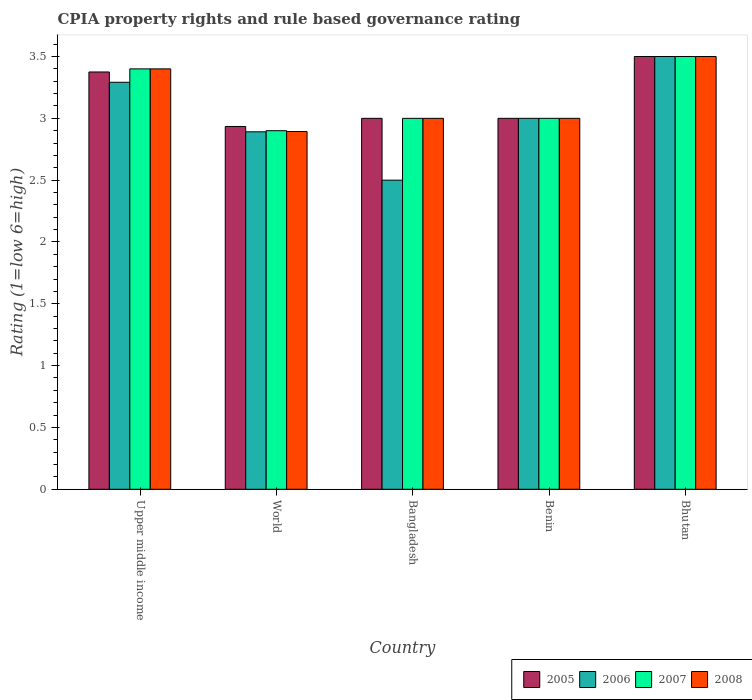How many different coloured bars are there?
Provide a succinct answer. 4. How many groups of bars are there?
Make the answer very short. 5. How many bars are there on the 3rd tick from the left?
Provide a succinct answer. 4. How many bars are there on the 2nd tick from the right?
Provide a succinct answer. 4. What is the label of the 5th group of bars from the left?
Offer a terse response. Bhutan. What is the CPIA rating in 2005 in World?
Provide a succinct answer. 2.93. Across all countries, what is the minimum CPIA rating in 2008?
Your response must be concise. 2.89. In which country was the CPIA rating in 2006 maximum?
Your answer should be very brief. Bhutan. What is the total CPIA rating in 2006 in the graph?
Provide a short and direct response. 15.18. What is the average CPIA rating in 2005 per country?
Offer a terse response. 3.16. What is the difference between the CPIA rating of/in 2007 and CPIA rating of/in 2005 in Benin?
Give a very brief answer. 0. In how many countries, is the CPIA rating in 2005 greater than 1.3?
Make the answer very short. 5. What is the ratio of the CPIA rating in 2007 in Bangladesh to that in Bhutan?
Your answer should be very brief. 0.86. Is the CPIA rating in 2007 in Bangladesh less than that in World?
Ensure brevity in your answer.  No. What is the difference between the highest and the second highest CPIA rating in 2005?
Make the answer very short. 0.38. What is the difference between the highest and the lowest CPIA rating in 2005?
Give a very brief answer. 0.57. In how many countries, is the CPIA rating in 2007 greater than the average CPIA rating in 2007 taken over all countries?
Offer a terse response. 2. Is the sum of the CPIA rating in 2006 in Bangladesh and Bhutan greater than the maximum CPIA rating in 2008 across all countries?
Keep it short and to the point. Yes. Is it the case that in every country, the sum of the CPIA rating in 2005 and CPIA rating in 2007 is greater than the sum of CPIA rating in 2006 and CPIA rating in 2008?
Give a very brief answer. No. What does the 2nd bar from the right in Benin represents?
Keep it short and to the point. 2007. Are the values on the major ticks of Y-axis written in scientific E-notation?
Provide a short and direct response. No. Does the graph contain any zero values?
Make the answer very short. No. Does the graph contain grids?
Your answer should be compact. No. What is the title of the graph?
Your response must be concise. CPIA property rights and rule based governance rating. Does "1994" appear as one of the legend labels in the graph?
Your answer should be very brief. No. What is the label or title of the Y-axis?
Offer a very short reply. Rating (1=low 6=high). What is the Rating (1=low 6=high) of 2005 in Upper middle income?
Provide a succinct answer. 3.38. What is the Rating (1=low 6=high) in 2006 in Upper middle income?
Provide a succinct answer. 3.29. What is the Rating (1=low 6=high) of 2005 in World?
Provide a short and direct response. 2.93. What is the Rating (1=low 6=high) of 2006 in World?
Offer a very short reply. 2.89. What is the Rating (1=low 6=high) in 2007 in World?
Provide a succinct answer. 2.9. What is the Rating (1=low 6=high) in 2008 in World?
Keep it short and to the point. 2.89. What is the Rating (1=low 6=high) of 2005 in Bangladesh?
Your response must be concise. 3. What is the Rating (1=low 6=high) in 2006 in Bangladesh?
Provide a short and direct response. 2.5. What is the Rating (1=low 6=high) in 2007 in Bangladesh?
Keep it short and to the point. 3. What is the Rating (1=low 6=high) of 2008 in Benin?
Ensure brevity in your answer.  3. What is the Rating (1=low 6=high) in 2005 in Bhutan?
Your answer should be very brief. 3.5. What is the Rating (1=low 6=high) in 2007 in Bhutan?
Keep it short and to the point. 3.5. What is the Rating (1=low 6=high) in 2008 in Bhutan?
Keep it short and to the point. 3.5. Across all countries, what is the maximum Rating (1=low 6=high) in 2005?
Offer a very short reply. 3.5. Across all countries, what is the maximum Rating (1=low 6=high) of 2007?
Ensure brevity in your answer.  3.5. Across all countries, what is the minimum Rating (1=low 6=high) in 2005?
Provide a short and direct response. 2.93. Across all countries, what is the minimum Rating (1=low 6=high) of 2006?
Your answer should be very brief. 2.5. Across all countries, what is the minimum Rating (1=low 6=high) of 2008?
Make the answer very short. 2.89. What is the total Rating (1=low 6=high) of 2005 in the graph?
Ensure brevity in your answer.  15.81. What is the total Rating (1=low 6=high) in 2006 in the graph?
Provide a succinct answer. 15.18. What is the total Rating (1=low 6=high) of 2007 in the graph?
Provide a short and direct response. 15.8. What is the total Rating (1=low 6=high) of 2008 in the graph?
Provide a short and direct response. 15.79. What is the difference between the Rating (1=low 6=high) of 2005 in Upper middle income and that in World?
Your answer should be compact. 0.44. What is the difference between the Rating (1=low 6=high) in 2006 in Upper middle income and that in World?
Provide a succinct answer. 0.4. What is the difference between the Rating (1=low 6=high) of 2008 in Upper middle income and that in World?
Your response must be concise. 0.51. What is the difference between the Rating (1=low 6=high) of 2006 in Upper middle income and that in Bangladesh?
Make the answer very short. 0.79. What is the difference between the Rating (1=low 6=high) in 2007 in Upper middle income and that in Bangladesh?
Your answer should be compact. 0.4. What is the difference between the Rating (1=low 6=high) of 2008 in Upper middle income and that in Bangladesh?
Provide a succinct answer. 0.4. What is the difference between the Rating (1=low 6=high) of 2005 in Upper middle income and that in Benin?
Provide a short and direct response. 0.38. What is the difference between the Rating (1=low 6=high) of 2006 in Upper middle income and that in Benin?
Offer a very short reply. 0.29. What is the difference between the Rating (1=low 6=high) in 2005 in Upper middle income and that in Bhutan?
Provide a succinct answer. -0.12. What is the difference between the Rating (1=low 6=high) of 2006 in Upper middle income and that in Bhutan?
Provide a succinct answer. -0.21. What is the difference between the Rating (1=low 6=high) in 2008 in Upper middle income and that in Bhutan?
Your response must be concise. -0.1. What is the difference between the Rating (1=low 6=high) in 2005 in World and that in Bangladesh?
Keep it short and to the point. -0.07. What is the difference between the Rating (1=low 6=high) of 2006 in World and that in Bangladesh?
Offer a very short reply. 0.39. What is the difference between the Rating (1=low 6=high) in 2007 in World and that in Bangladesh?
Offer a terse response. -0.1. What is the difference between the Rating (1=low 6=high) of 2008 in World and that in Bangladesh?
Ensure brevity in your answer.  -0.11. What is the difference between the Rating (1=low 6=high) of 2005 in World and that in Benin?
Offer a terse response. -0.07. What is the difference between the Rating (1=low 6=high) of 2006 in World and that in Benin?
Keep it short and to the point. -0.11. What is the difference between the Rating (1=low 6=high) in 2008 in World and that in Benin?
Provide a short and direct response. -0.11. What is the difference between the Rating (1=low 6=high) in 2005 in World and that in Bhutan?
Keep it short and to the point. -0.57. What is the difference between the Rating (1=low 6=high) in 2006 in World and that in Bhutan?
Provide a short and direct response. -0.61. What is the difference between the Rating (1=low 6=high) of 2007 in World and that in Bhutan?
Give a very brief answer. -0.6. What is the difference between the Rating (1=low 6=high) in 2008 in World and that in Bhutan?
Offer a very short reply. -0.61. What is the difference between the Rating (1=low 6=high) of 2007 in Bangladesh and that in Benin?
Your answer should be compact. 0. What is the difference between the Rating (1=low 6=high) in 2005 in Bangladesh and that in Bhutan?
Make the answer very short. -0.5. What is the difference between the Rating (1=low 6=high) of 2007 in Bangladesh and that in Bhutan?
Make the answer very short. -0.5. What is the difference between the Rating (1=low 6=high) of 2005 in Benin and that in Bhutan?
Provide a succinct answer. -0.5. What is the difference between the Rating (1=low 6=high) in 2007 in Benin and that in Bhutan?
Give a very brief answer. -0.5. What is the difference between the Rating (1=low 6=high) of 2008 in Benin and that in Bhutan?
Give a very brief answer. -0.5. What is the difference between the Rating (1=low 6=high) in 2005 in Upper middle income and the Rating (1=low 6=high) in 2006 in World?
Provide a succinct answer. 0.48. What is the difference between the Rating (1=low 6=high) in 2005 in Upper middle income and the Rating (1=low 6=high) in 2007 in World?
Provide a succinct answer. 0.47. What is the difference between the Rating (1=low 6=high) in 2005 in Upper middle income and the Rating (1=low 6=high) in 2008 in World?
Provide a short and direct response. 0.48. What is the difference between the Rating (1=low 6=high) of 2006 in Upper middle income and the Rating (1=low 6=high) of 2007 in World?
Ensure brevity in your answer.  0.39. What is the difference between the Rating (1=low 6=high) in 2006 in Upper middle income and the Rating (1=low 6=high) in 2008 in World?
Give a very brief answer. 0.4. What is the difference between the Rating (1=low 6=high) of 2007 in Upper middle income and the Rating (1=low 6=high) of 2008 in World?
Give a very brief answer. 0.51. What is the difference between the Rating (1=low 6=high) of 2005 in Upper middle income and the Rating (1=low 6=high) of 2006 in Bangladesh?
Your response must be concise. 0.88. What is the difference between the Rating (1=low 6=high) of 2005 in Upper middle income and the Rating (1=low 6=high) of 2007 in Bangladesh?
Your answer should be very brief. 0.38. What is the difference between the Rating (1=low 6=high) in 2005 in Upper middle income and the Rating (1=low 6=high) in 2008 in Bangladesh?
Give a very brief answer. 0.38. What is the difference between the Rating (1=low 6=high) of 2006 in Upper middle income and the Rating (1=low 6=high) of 2007 in Bangladesh?
Your answer should be very brief. 0.29. What is the difference between the Rating (1=low 6=high) of 2006 in Upper middle income and the Rating (1=low 6=high) of 2008 in Bangladesh?
Provide a short and direct response. 0.29. What is the difference between the Rating (1=low 6=high) of 2005 in Upper middle income and the Rating (1=low 6=high) of 2007 in Benin?
Your answer should be compact. 0.38. What is the difference between the Rating (1=low 6=high) in 2006 in Upper middle income and the Rating (1=low 6=high) in 2007 in Benin?
Provide a succinct answer. 0.29. What is the difference between the Rating (1=low 6=high) of 2006 in Upper middle income and the Rating (1=low 6=high) of 2008 in Benin?
Keep it short and to the point. 0.29. What is the difference between the Rating (1=low 6=high) in 2005 in Upper middle income and the Rating (1=low 6=high) in 2006 in Bhutan?
Provide a short and direct response. -0.12. What is the difference between the Rating (1=low 6=high) of 2005 in Upper middle income and the Rating (1=low 6=high) of 2007 in Bhutan?
Give a very brief answer. -0.12. What is the difference between the Rating (1=low 6=high) of 2005 in Upper middle income and the Rating (1=low 6=high) of 2008 in Bhutan?
Your response must be concise. -0.12. What is the difference between the Rating (1=low 6=high) of 2006 in Upper middle income and the Rating (1=low 6=high) of 2007 in Bhutan?
Your answer should be very brief. -0.21. What is the difference between the Rating (1=low 6=high) of 2006 in Upper middle income and the Rating (1=low 6=high) of 2008 in Bhutan?
Ensure brevity in your answer.  -0.21. What is the difference between the Rating (1=low 6=high) in 2005 in World and the Rating (1=low 6=high) in 2006 in Bangladesh?
Your answer should be compact. 0.43. What is the difference between the Rating (1=low 6=high) of 2005 in World and the Rating (1=low 6=high) of 2007 in Bangladesh?
Keep it short and to the point. -0.07. What is the difference between the Rating (1=low 6=high) in 2005 in World and the Rating (1=low 6=high) in 2008 in Bangladesh?
Your answer should be very brief. -0.07. What is the difference between the Rating (1=low 6=high) of 2006 in World and the Rating (1=low 6=high) of 2007 in Bangladesh?
Your answer should be very brief. -0.11. What is the difference between the Rating (1=low 6=high) of 2006 in World and the Rating (1=low 6=high) of 2008 in Bangladesh?
Your answer should be compact. -0.11. What is the difference between the Rating (1=low 6=high) in 2005 in World and the Rating (1=low 6=high) in 2006 in Benin?
Your response must be concise. -0.07. What is the difference between the Rating (1=low 6=high) of 2005 in World and the Rating (1=low 6=high) of 2007 in Benin?
Provide a short and direct response. -0.07. What is the difference between the Rating (1=low 6=high) in 2005 in World and the Rating (1=low 6=high) in 2008 in Benin?
Your answer should be very brief. -0.07. What is the difference between the Rating (1=low 6=high) in 2006 in World and the Rating (1=low 6=high) in 2007 in Benin?
Offer a terse response. -0.11. What is the difference between the Rating (1=low 6=high) in 2006 in World and the Rating (1=low 6=high) in 2008 in Benin?
Give a very brief answer. -0.11. What is the difference between the Rating (1=low 6=high) in 2007 in World and the Rating (1=low 6=high) in 2008 in Benin?
Give a very brief answer. -0.1. What is the difference between the Rating (1=low 6=high) in 2005 in World and the Rating (1=low 6=high) in 2006 in Bhutan?
Your answer should be compact. -0.57. What is the difference between the Rating (1=low 6=high) in 2005 in World and the Rating (1=low 6=high) in 2007 in Bhutan?
Provide a short and direct response. -0.57. What is the difference between the Rating (1=low 6=high) of 2005 in World and the Rating (1=low 6=high) of 2008 in Bhutan?
Offer a very short reply. -0.57. What is the difference between the Rating (1=low 6=high) of 2006 in World and the Rating (1=low 6=high) of 2007 in Bhutan?
Your answer should be compact. -0.61. What is the difference between the Rating (1=low 6=high) in 2006 in World and the Rating (1=low 6=high) in 2008 in Bhutan?
Provide a short and direct response. -0.61. What is the difference between the Rating (1=low 6=high) of 2005 in Bangladesh and the Rating (1=low 6=high) of 2006 in Benin?
Provide a short and direct response. 0. What is the difference between the Rating (1=low 6=high) of 2005 in Bangladesh and the Rating (1=low 6=high) of 2008 in Benin?
Your response must be concise. 0. What is the difference between the Rating (1=low 6=high) of 2006 in Bangladesh and the Rating (1=low 6=high) of 2007 in Benin?
Your response must be concise. -0.5. What is the difference between the Rating (1=low 6=high) of 2006 in Bangladesh and the Rating (1=low 6=high) of 2008 in Benin?
Keep it short and to the point. -0.5. What is the difference between the Rating (1=low 6=high) in 2007 in Bangladesh and the Rating (1=low 6=high) in 2008 in Benin?
Give a very brief answer. 0. What is the difference between the Rating (1=low 6=high) of 2005 in Bangladesh and the Rating (1=low 6=high) of 2007 in Bhutan?
Make the answer very short. -0.5. What is the difference between the Rating (1=low 6=high) of 2005 in Bangladesh and the Rating (1=low 6=high) of 2008 in Bhutan?
Give a very brief answer. -0.5. What is the difference between the Rating (1=low 6=high) in 2006 in Bangladesh and the Rating (1=low 6=high) in 2007 in Bhutan?
Keep it short and to the point. -1. What is the difference between the Rating (1=low 6=high) of 2006 in Bangladesh and the Rating (1=low 6=high) of 2008 in Bhutan?
Give a very brief answer. -1. What is the difference between the Rating (1=low 6=high) in 2005 in Benin and the Rating (1=low 6=high) in 2008 in Bhutan?
Your response must be concise. -0.5. What is the difference between the Rating (1=low 6=high) of 2006 in Benin and the Rating (1=low 6=high) of 2007 in Bhutan?
Provide a short and direct response. -0.5. What is the difference between the Rating (1=low 6=high) in 2006 in Benin and the Rating (1=low 6=high) in 2008 in Bhutan?
Give a very brief answer. -0.5. What is the difference between the Rating (1=low 6=high) of 2007 in Benin and the Rating (1=low 6=high) of 2008 in Bhutan?
Ensure brevity in your answer.  -0.5. What is the average Rating (1=low 6=high) in 2005 per country?
Offer a terse response. 3.16. What is the average Rating (1=low 6=high) of 2006 per country?
Give a very brief answer. 3.04. What is the average Rating (1=low 6=high) of 2007 per country?
Make the answer very short. 3.16. What is the average Rating (1=low 6=high) in 2008 per country?
Give a very brief answer. 3.16. What is the difference between the Rating (1=low 6=high) of 2005 and Rating (1=low 6=high) of 2006 in Upper middle income?
Your response must be concise. 0.08. What is the difference between the Rating (1=low 6=high) of 2005 and Rating (1=low 6=high) of 2007 in Upper middle income?
Offer a terse response. -0.03. What is the difference between the Rating (1=low 6=high) in 2005 and Rating (1=low 6=high) in 2008 in Upper middle income?
Make the answer very short. -0.03. What is the difference between the Rating (1=low 6=high) in 2006 and Rating (1=low 6=high) in 2007 in Upper middle income?
Your answer should be very brief. -0.11. What is the difference between the Rating (1=low 6=high) in 2006 and Rating (1=low 6=high) in 2008 in Upper middle income?
Provide a short and direct response. -0.11. What is the difference between the Rating (1=low 6=high) in 2007 and Rating (1=low 6=high) in 2008 in Upper middle income?
Keep it short and to the point. 0. What is the difference between the Rating (1=low 6=high) in 2005 and Rating (1=low 6=high) in 2006 in World?
Offer a terse response. 0.04. What is the difference between the Rating (1=low 6=high) of 2005 and Rating (1=low 6=high) of 2007 in World?
Provide a succinct answer. 0.03. What is the difference between the Rating (1=low 6=high) of 2005 and Rating (1=low 6=high) of 2008 in World?
Your answer should be compact. 0.04. What is the difference between the Rating (1=low 6=high) in 2006 and Rating (1=low 6=high) in 2007 in World?
Your response must be concise. -0.01. What is the difference between the Rating (1=low 6=high) in 2006 and Rating (1=low 6=high) in 2008 in World?
Keep it short and to the point. -0. What is the difference between the Rating (1=low 6=high) of 2007 and Rating (1=low 6=high) of 2008 in World?
Provide a short and direct response. 0.01. What is the difference between the Rating (1=low 6=high) in 2005 and Rating (1=low 6=high) in 2006 in Bangladesh?
Your answer should be very brief. 0.5. What is the difference between the Rating (1=low 6=high) in 2005 and Rating (1=low 6=high) in 2007 in Bangladesh?
Offer a terse response. 0. What is the difference between the Rating (1=low 6=high) in 2005 and Rating (1=low 6=high) in 2008 in Bangladesh?
Your answer should be very brief. 0. What is the difference between the Rating (1=low 6=high) in 2006 and Rating (1=low 6=high) in 2007 in Bangladesh?
Offer a terse response. -0.5. What is the difference between the Rating (1=low 6=high) of 2006 and Rating (1=low 6=high) of 2008 in Bangladesh?
Keep it short and to the point. -0.5. What is the difference between the Rating (1=low 6=high) in 2005 and Rating (1=low 6=high) in 2006 in Benin?
Ensure brevity in your answer.  0. What is the difference between the Rating (1=low 6=high) in 2005 and Rating (1=low 6=high) in 2008 in Benin?
Give a very brief answer. 0. What is the difference between the Rating (1=low 6=high) in 2006 and Rating (1=low 6=high) in 2008 in Benin?
Make the answer very short. 0. What is the difference between the Rating (1=low 6=high) in 2005 and Rating (1=low 6=high) in 2006 in Bhutan?
Offer a very short reply. 0. What is the difference between the Rating (1=low 6=high) of 2005 and Rating (1=low 6=high) of 2007 in Bhutan?
Ensure brevity in your answer.  0. What is the difference between the Rating (1=low 6=high) in 2005 and Rating (1=low 6=high) in 2008 in Bhutan?
Offer a terse response. 0. What is the ratio of the Rating (1=low 6=high) in 2005 in Upper middle income to that in World?
Your answer should be very brief. 1.15. What is the ratio of the Rating (1=low 6=high) of 2006 in Upper middle income to that in World?
Keep it short and to the point. 1.14. What is the ratio of the Rating (1=low 6=high) of 2007 in Upper middle income to that in World?
Provide a succinct answer. 1.17. What is the ratio of the Rating (1=low 6=high) of 2008 in Upper middle income to that in World?
Ensure brevity in your answer.  1.18. What is the ratio of the Rating (1=low 6=high) in 2005 in Upper middle income to that in Bangladesh?
Provide a succinct answer. 1.12. What is the ratio of the Rating (1=low 6=high) of 2006 in Upper middle income to that in Bangladesh?
Your response must be concise. 1.32. What is the ratio of the Rating (1=low 6=high) in 2007 in Upper middle income to that in Bangladesh?
Your response must be concise. 1.13. What is the ratio of the Rating (1=low 6=high) in 2008 in Upper middle income to that in Bangladesh?
Your answer should be compact. 1.13. What is the ratio of the Rating (1=low 6=high) in 2006 in Upper middle income to that in Benin?
Give a very brief answer. 1.1. What is the ratio of the Rating (1=low 6=high) in 2007 in Upper middle income to that in Benin?
Your answer should be compact. 1.13. What is the ratio of the Rating (1=low 6=high) of 2008 in Upper middle income to that in Benin?
Provide a short and direct response. 1.13. What is the ratio of the Rating (1=low 6=high) in 2005 in Upper middle income to that in Bhutan?
Your response must be concise. 0.96. What is the ratio of the Rating (1=low 6=high) in 2006 in Upper middle income to that in Bhutan?
Offer a very short reply. 0.94. What is the ratio of the Rating (1=low 6=high) in 2007 in Upper middle income to that in Bhutan?
Give a very brief answer. 0.97. What is the ratio of the Rating (1=low 6=high) of 2008 in Upper middle income to that in Bhutan?
Give a very brief answer. 0.97. What is the ratio of the Rating (1=low 6=high) of 2005 in World to that in Bangladesh?
Your answer should be compact. 0.98. What is the ratio of the Rating (1=low 6=high) in 2006 in World to that in Bangladesh?
Your answer should be very brief. 1.16. What is the ratio of the Rating (1=low 6=high) of 2007 in World to that in Bangladesh?
Provide a succinct answer. 0.97. What is the ratio of the Rating (1=low 6=high) in 2008 in World to that in Bangladesh?
Keep it short and to the point. 0.96. What is the ratio of the Rating (1=low 6=high) in 2005 in World to that in Benin?
Ensure brevity in your answer.  0.98. What is the ratio of the Rating (1=low 6=high) of 2006 in World to that in Benin?
Ensure brevity in your answer.  0.96. What is the ratio of the Rating (1=low 6=high) of 2007 in World to that in Benin?
Your response must be concise. 0.97. What is the ratio of the Rating (1=low 6=high) of 2008 in World to that in Benin?
Provide a short and direct response. 0.96. What is the ratio of the Rating (1=low 6=high) of 2005 in World to that in Bhutan?
Keep it short and to the point. 0.84. What is the ratio of the Rating (1=low 6=high) in 2006 in World to that in Bhutan?
Make the answer very short. 0.83. What is the ratio of the Rating (1=low 6=high) in 2007 in World to that in Bhutan?
Ensure brevity in your answer.  0.83. What is the ratio of the Rating (1=low 6=high) of 2008 in World to that in Bhutan?
Ensure brevity in your answer.  0.83. What is the ratio of the Rating (1=low 6=high) of 2006 in Bangladesh to that in Benin?
Your response must be concise. 0.83. What is the ratio of the Rating (1=low 6=high) in 2007 in Bangladesh to that in Benin?
Your answer should be compact. 1. What is the ratio of the Rating (1=low 6=high) in 2008 in Bangladesh to that in Benin?
Your response must be concise. 1. What is the ratio of the Rating (1=low 6=high) of 2005 in Bangladesh to that in Bhutan?
Make the answer very short. 0.86. What is the ratio of the Rating (1=low 6=high) of 2005 in Benin to that in Bhutan?
Give a very brief answer. 0.86. What is the ratio of the Rating (1=low 6=high) in 2007 in Benin to that in Bhutan?
Give a very brief answer. 0.86. What is the ratio of the Rating (1=low 6=high) of 2008 in Benin to that in Bhutan?
Your answer should be compact. 0.86. What is the difference between the highest and the second highest Rating (1=low 6=high) of 2006?
Keep it short and to the point. 0.21. What is the difference between the highest and the second highest Rating (1=low 6=high) in 2007?
Offer a terse response. 0.1. What is the difference between the highest and the lowest Rating (1=low 6=high) in 2005?
Provide a succinct answer. 0.57. What is the difference between the highest and the lowest Rating (1=low 6=high) in 2008?
Provide a short and direct response. 0.61. 